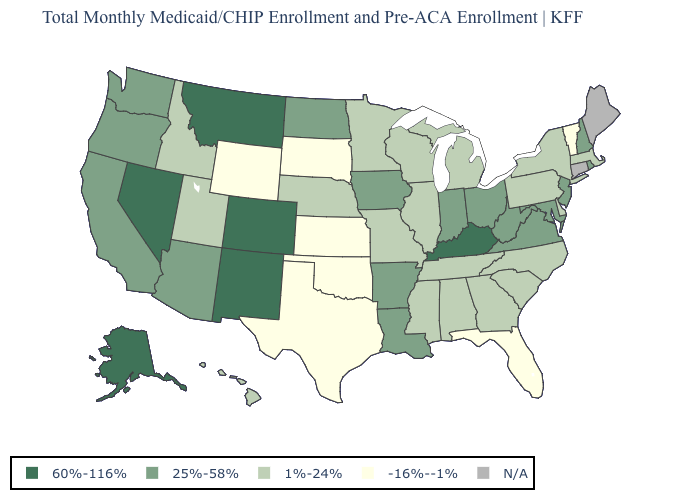What is the value of Washington?
Keep it brief. 25%-58%. Among the states that border Michigan , which have the highest value?
Be succinct. Indiana, Ohio. Name the states that have a value in the range -16%--1%?
Short answer required. Florida, Kansas, Oklahoma, South Dakota, Texas, Vermont, Wyoming. Does the first symbol in the legend represent the smallest category?
Quick response, please. No. Among the states that border West Virginia , which have the lowest value?
Answer briefly. Pennsylvania. What is the lowest value in states that border Mississippi?
Short answer required. 1%-24%. Among the states that border Maryland , which have the highest value?
Answer briefly. Virginia, West Virginia. What is the highest value in the USA?
Be succinct. 60%-116%. Is the legend a continuous bar?
Short answer required. No. Does the first symbol in the legend represent the smallest category?
Concise answer only. No. Among the states that border Utah , which have the highest value?
Quick response, please. Colorado, Nevada, New Mexico. What is the highest value in states that border Kentucky?
Be succinct. 25%-58%. What is the value of Iowa?
Short answer required. 25%-58%. What is the highest value in the MidWest ?
Answer briefly. 25%-58%. 